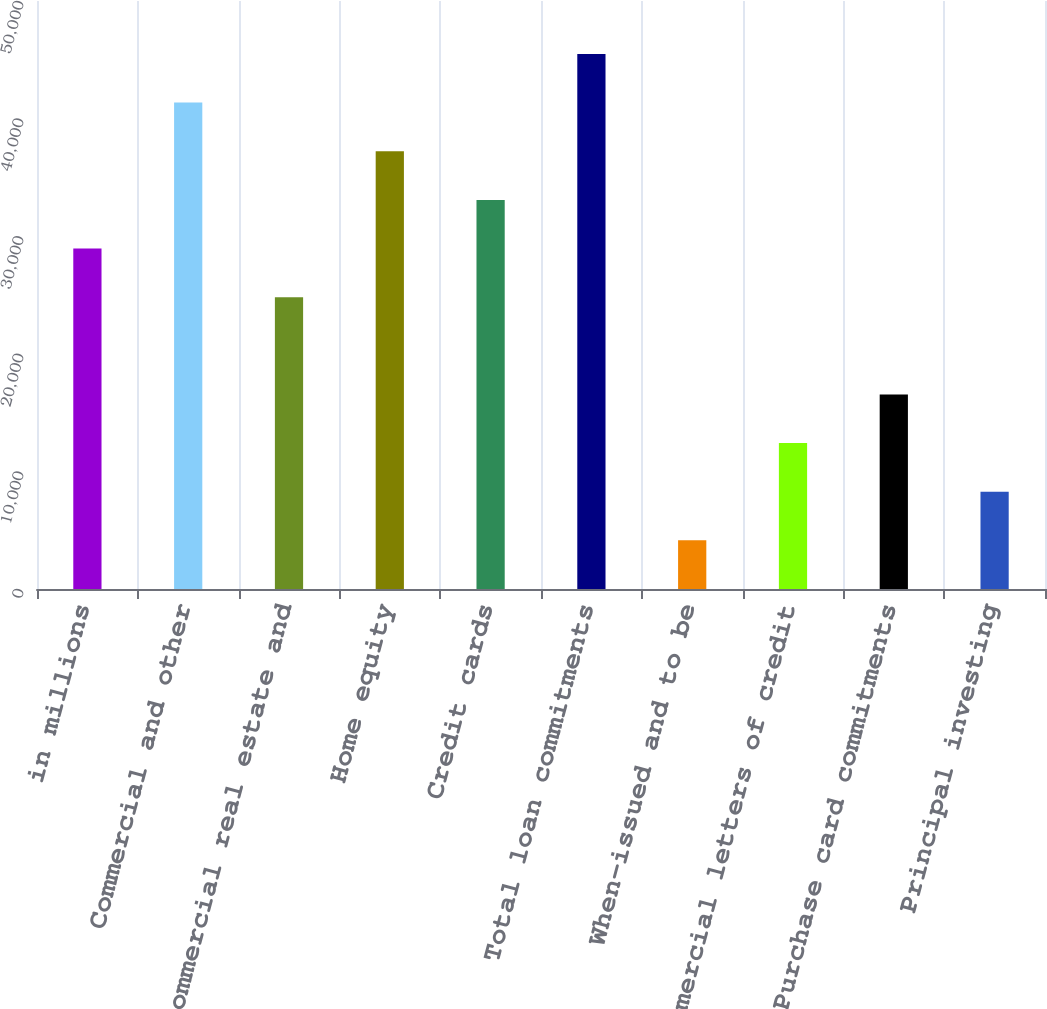<chart> <loc_0><loc_0><loc_500><loc_500><bar_chart><fcel>in millions<fcel>Commercial and other<fcel>Commercial real estate and<fcel>Home equity<fcel>Credit cards<fcel>Total loan commitments<fcel>When-issued and to be<fcel>Commercial letters of credit<fcel>Purchase card commitments<fcel>Principal investing<nl><fcel>28951.6<fcel>41359<fcel>24815.8<fcel>37223.2<fcel>33087.4<fcel>45494.8<fcel>4136.8<fcel>12408.4<fcel>16544.2<fcel>8272.6<nl></chart> 